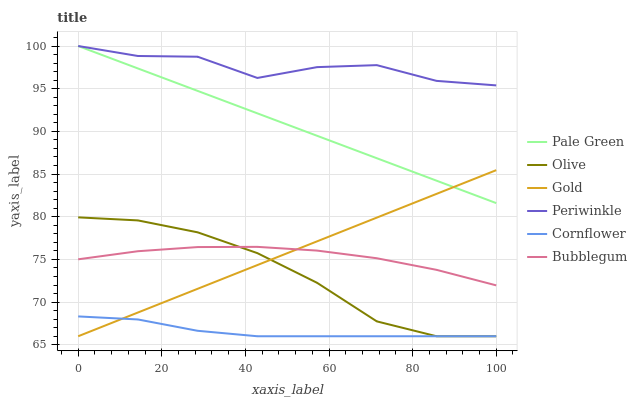Does Cornflower have the minimum area under the curve?
Answer yes or no. Yes. Does Periwinkle have the maximum area under the curve?
Answer yes or no. Yes. Does Gold have the minimum area under the curve?
Answer yes or no. No. Does Gold have the maximum area under the curve?
Answer yes or no. No. Is Pale Green the smoothest?
Answer yes or no. Yes. Is Periwinkle the roughest?
Answer yes or no. Yes. Is Gold the smoothest?
Answer yes or no. No. Is Gold the roughest?
Answer yes or no. No. Does Cornflower have the lowest value?
Answer yes or no. Yes. Does Bubblegum have the lowest value?
Answer yes or no. No. Does Periwinkle have the highest value?
Answer yes or no. Yes. Does Gold have the highest value?
Answer yes or no. No. Is Cornflower less than Pale Green?
Answer yes or no. Yes. Is Pale Green greater than Olive?
Answer yes or no. Yes. Does Gold intersect Olive?
Answer yes or no. Yes. Is Gold less than Olive?
Answer yes or no. No. Is Gold greater than Olive?
Answer yes or no. No. Does Cornflower intersect Pale Green?
Answer yes or no. No. 